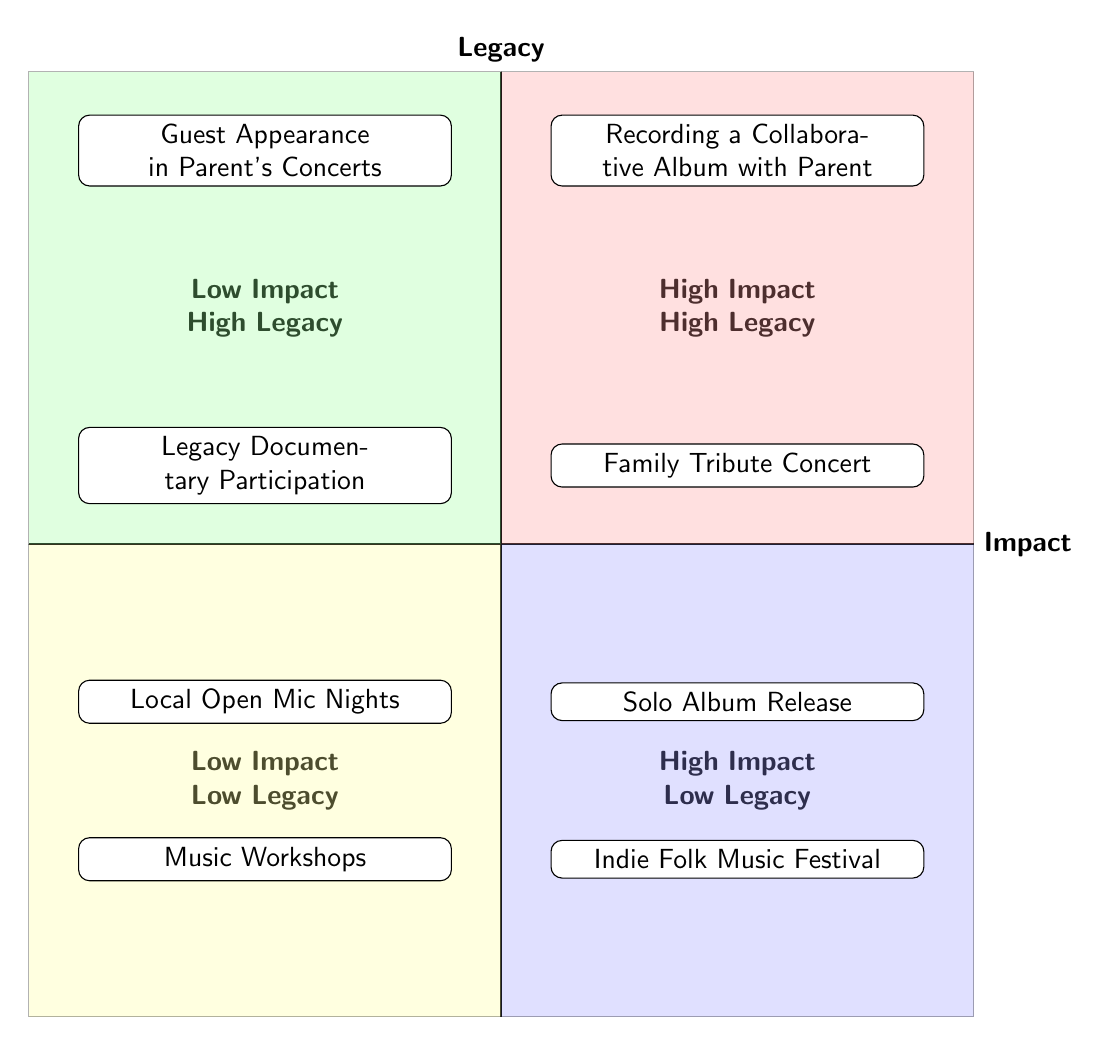What are the two elements in the High Impact - High Legacy quadrant? The High Impact - High Legacy quadrant contains the elements "Recording a Collaborative Album with Parent" and "Family Tribute Concert."
Answer: Recording a Collaborative Album with Parent, Family Tribute Concert How many elements are in the Low Impact - Low Legacy quadrant? The Low Impact - Low Legacy quadrant contains two elements: "Local Open Mic Nights" and "Music Workshops." Therefore, there are a total of two elements in this quadrant.
Answer: 2 Which quadrant contains elements related to both personal projects and legacy commitments? The High Impact - High Legacy quadrant contains elements that blend personal projects with commitments to legacy, such as "Recording a Collaborative Album with Parent" and "Family Tribute Concert."
Answer: High Impact - High Legacy What is the description of the element "Solo Album Release"? Checking the Low Impact - Low Legacy quadrant shows that "Solo Album Release" is defined as "Focus on creating and releasing a solo album that emphasizes your style and individuality."
Answer: Focus on creating and releasing a solo album that emphasizes your style and individuality Which element has the lowest impact and low legacy? The elements in the Low Impact - Low Legacy quadrant include "Local Open Mic Nights" and "Music Workshops." Therefore, these are the elements with the lowest impact and low legacy.
Answer: Local Open Mic Nights, Music Workshops How do the "Family Tribute Concert" and "Guest Appearance in Parent's Concerts" differ in terms of impact? "Family Tribute Concert" is in the High Impact quadrant, while "Guest Appearance in Parent's Concerts" is in the Low Impact quadrant, highlighting a significant difference in their impact on your career.
Answer: Family Tribute Concert is High Impact; Guest Appearance is Low Impact 